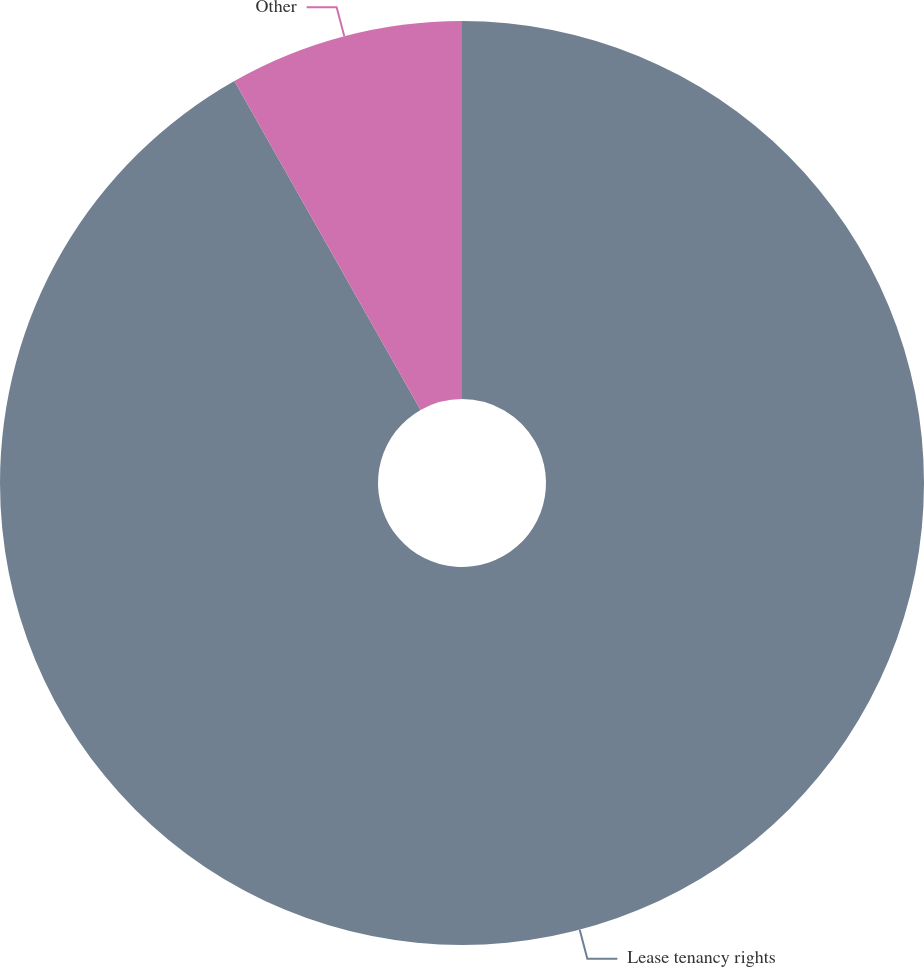<chart> <loc_0><loc_0><loc_500><loc_500><pie_chart><fcel>Lease tenancy rights<fcel>Other<nl><fcel>91.8%<fcel>8.2%<nl></chart> 